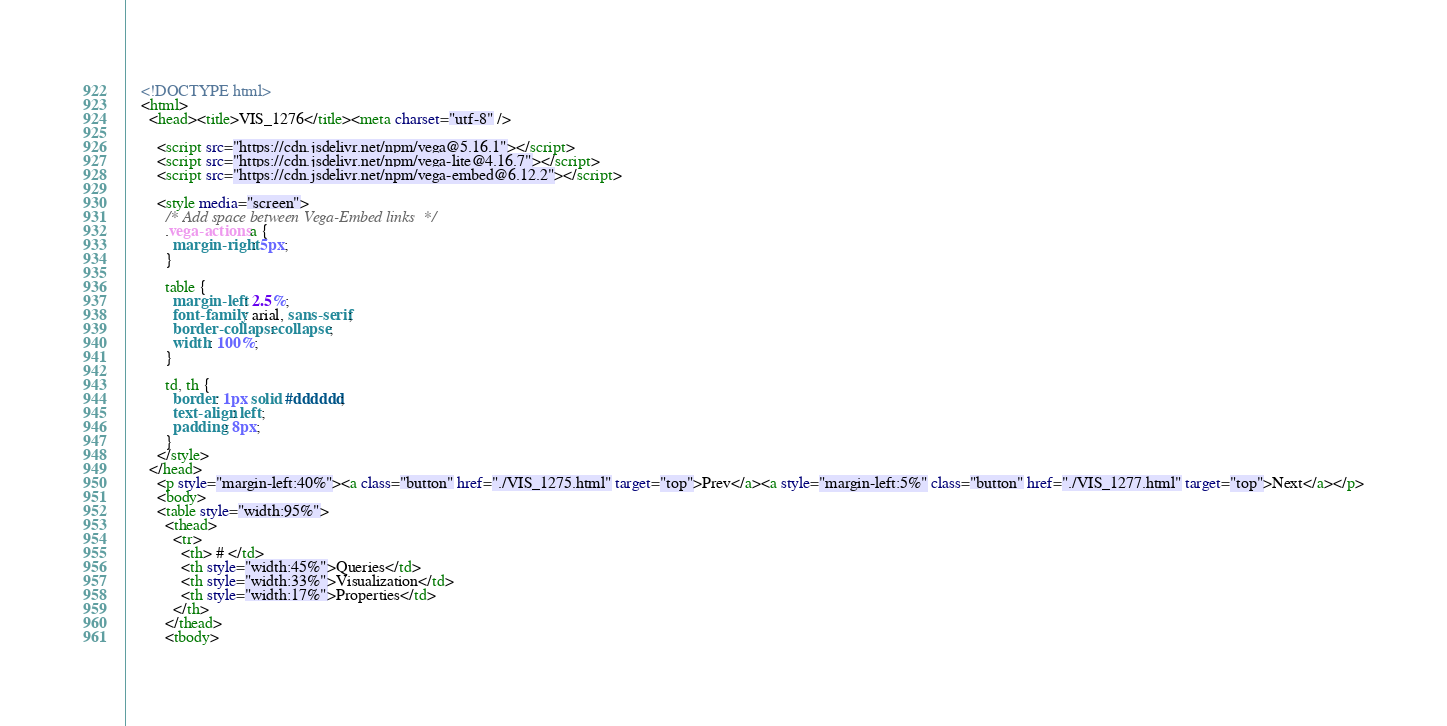<code> <loc_0><loc_0><loc_500><loc_500><_HTML_>
    <!DOCTYPE html>
    <html>
      <head><title>VIS_1276</title><meta charset="utf-8" />

        <script src="https://cdn.jsdelivr.net/npm/vega@5.16.1"></script>
        <script src="https://cdn.jsdelivr.net/npm/vega-lite@4.16.7"></script>
        <script src="https://cdn.jsdelivr.net/npm/vega-embed@6.12.2"></script>

        <style media="screen">
          /* Add space between Vega-Embed links  */
          .vega-actions a {
            margin-right: 5px;
          }

          table {
            margin-left: 2.5%;
            font-family: arial, sans-serif;
            border-collapse: collapse;
            width: 100%;
          }

          td, th {
            border: 1px solid #dddddd;
            text-align: left;
            padding: 8px;
          }
        </style>
      </head>
        <p style="margin-left:40%"><a class="button" href="./VIS_1275.html" target="top">Prev</a><a style="margin-left:5%" class="button" href="./VIS_1277.html" target="top">Next</a></p>
        <body>
        <table style="width:95%">
          <thead>
            <tr>
              <th> # </td>
              <th style="width:45%">Queries</td>
              <th style="width:33%">Visualization</td>
              <th style="width:17%">Properties</td>
            </th>
          </thead>
          <tbody></code> 